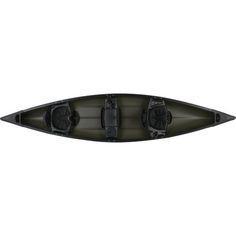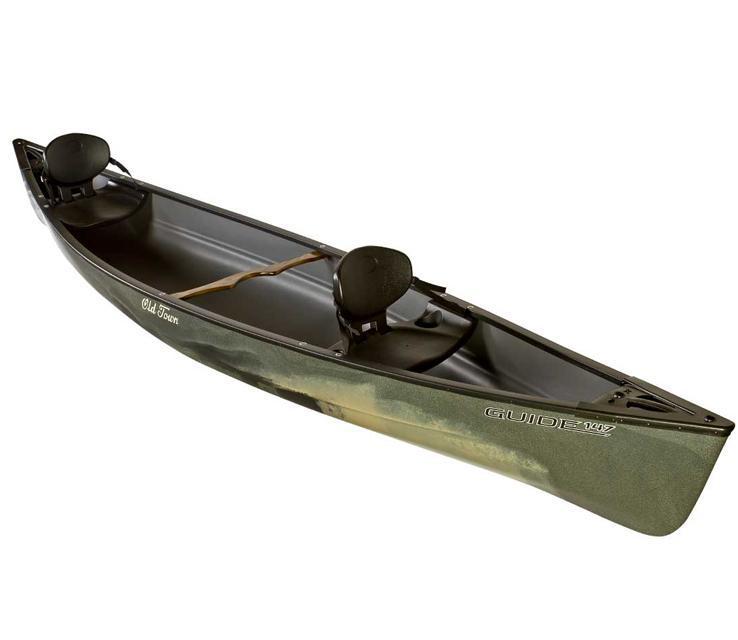The first image is the image on the left, the second image is the image on the right. For the images displayed, is the sentence "One of the boats does not contain seats with backrests." factually correct? Answer yes or no. No. The first image is the image on the left, the second image is the image on the right. Examine the images to the left and right. Is the description "There are four upright boats." accurate? Answer yes or no. No. 